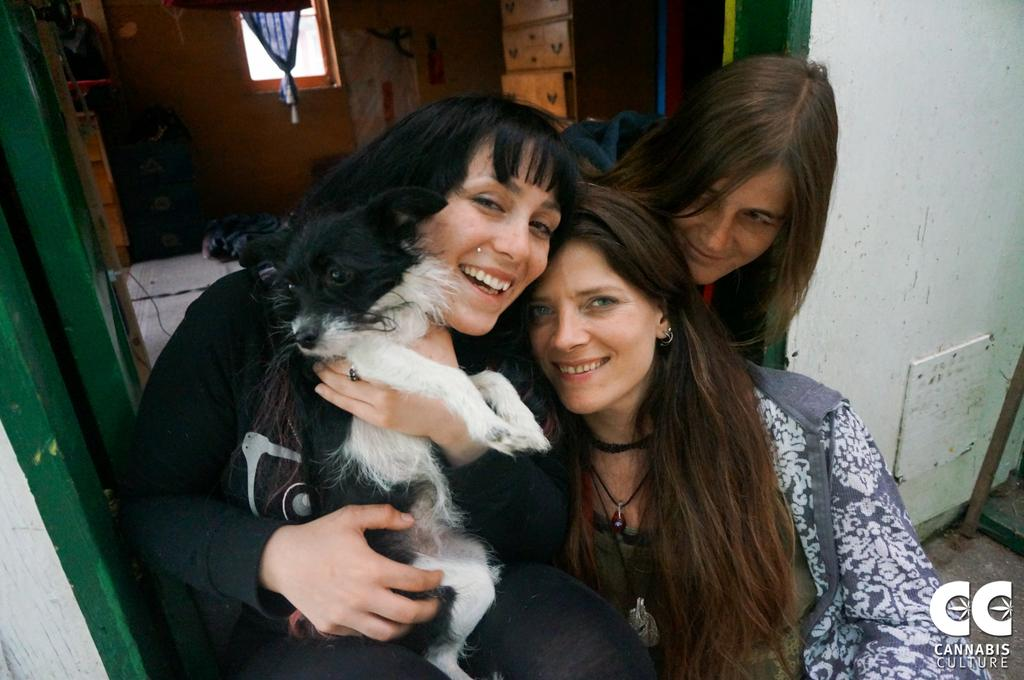How many women are present in the image? There are three women in the image. What is one of the women doing with her hands? One of the women is holding a dog in her hands. What can be seen in the background of the image? There is a window, a wall, a curtain, cupboards, and a door in the background of the image. What type of juice is being served in the image? There is no juice present in the image. How many snakes can be seen slithering on the floor in the image? There are no snakes present in the image. 